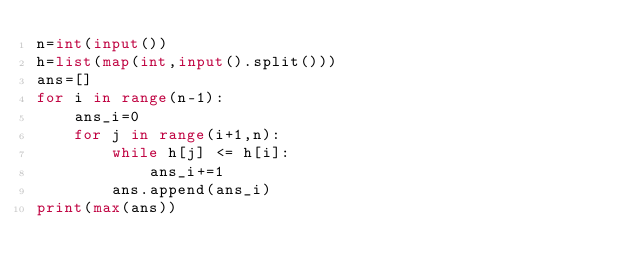Convert code to text. <code><loc_0><loc_0><loc_500><loc_500><_Python_>n=int(input())
h=list(map(int,input().split()))
ans=[]
for i in range(n-1):
    ans_i=0
    for j in range(i+1,n):
        while h[j] <= h[i]:
            ans_i+=1
        ans.append(ans_i)
print(max(ans))</code> 